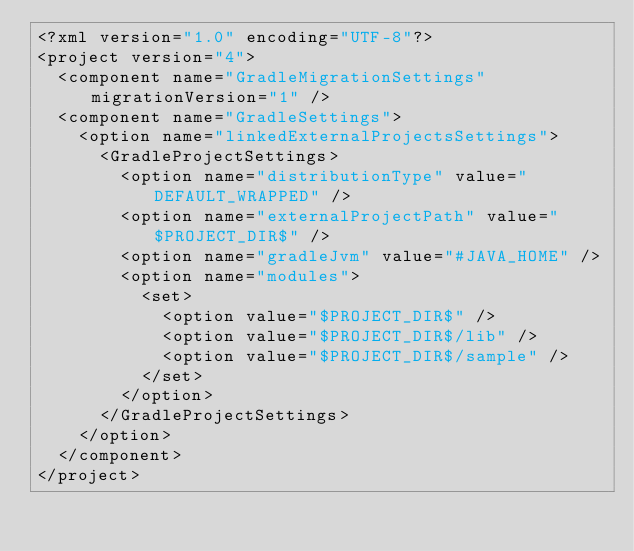<code> <loc_0><loc_0><loc_500><loc_500><_XML_><?xml version="1.0" encoding="UTF-8"?>
<project version="4">
  <component name="GradleMigrationSettings" migrationVersion="1" />
  <component name="GradleSettings">
    <option name="linkedExternalProjectsSettings">
      <GradleProjectSettings>
        <option name="distributionType" value="DEFAULT_WRAPPED" />
        <option name="externalProjectPath" value="$PROJECT_DIR$" />
        <option name="gradleJvm" value="#JAVA_HOME" />
        <option name="modules">
          <set>
            <option value="$PROJECT_DIR$" />
            <option value="$PROJECT_DIR$/lib" />
            <option value="$PROJECT_DIR$/sample" />
          </set>
        </option>
      </GradleProjectSettings>
    </option>
  </component>
</project></code> 